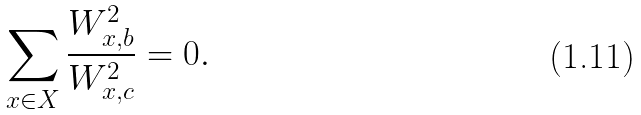<formula> <loc_0><loc_0><loc_500><loc_500>\sum _ { x \in X } \frac { W _ { x , b } ^ { 2 } } { W _ { x , c } ^ { 2 } } = 0 .</formula> 